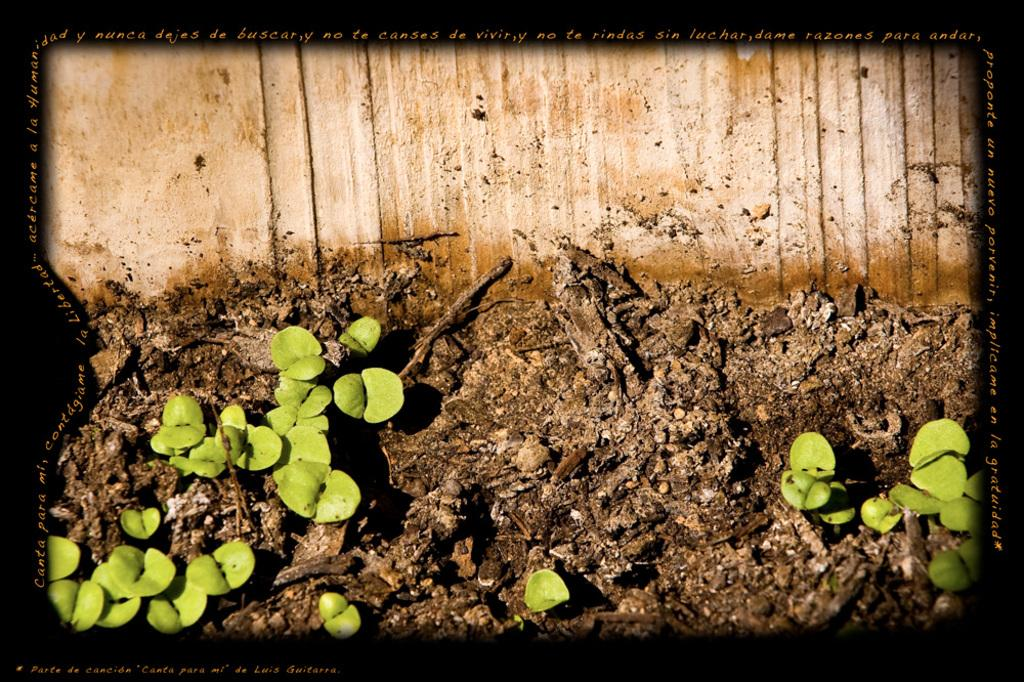What can be inferred about the nature of the image? The image is edited. What type of natural elements can be seen in the image? There are plants in the image. What type of structure is present in the image? There is a wall in the image. What color is used for the borders of the image? The borders of the image are black. What type of additional information is present in the image? There is some text in the image. What type of bedroom furniture can be seen in the image? There is no bedroom furniture present in the image. What is the height of the side of the wall in the image? The image does not provide information about the height of the wall or any specific side. 